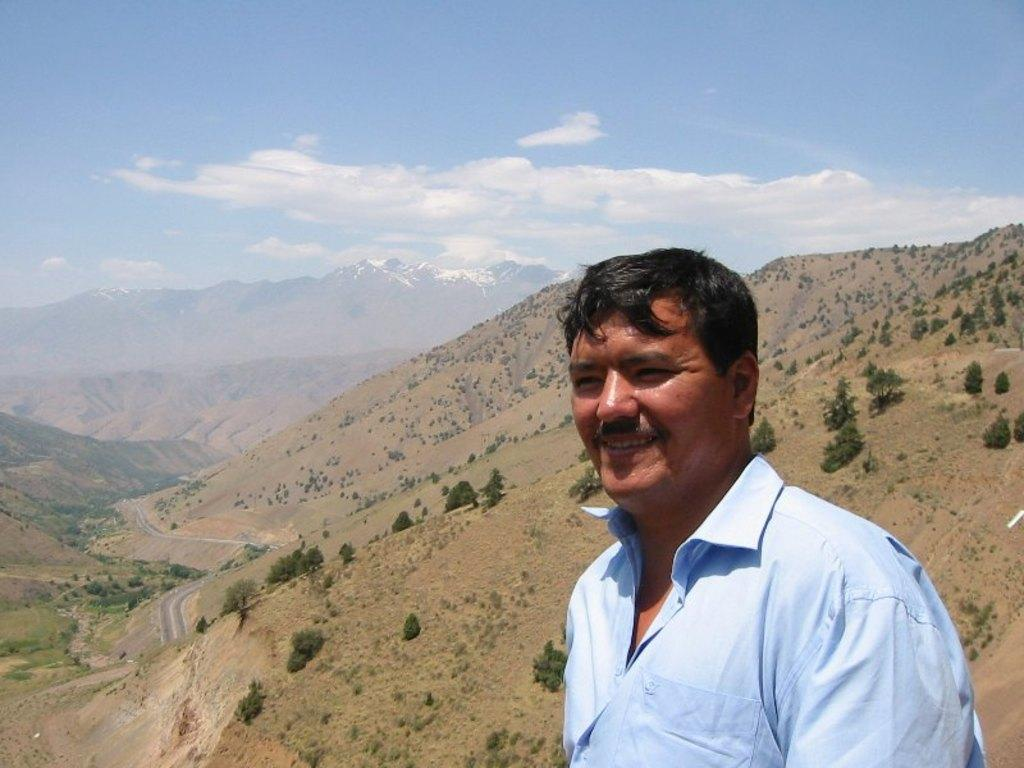What is the main subject of the image? There is a person in the image. What is the person wearing? The person is wearing a blue shirt. What is the person's facial expression? The person is smiling. What can be seen in the background of the image? There are mountains, trees, a road, and the sky visible in the background. How many dogs are sitting at the dinner table with the person in the image? There are no dogs or dinner table present in the image. What type of zebra can be seen grazing on the mountains in the background? There is no zebra present in the image; only mountains, trees, a road, and the sky are visible in the background. 